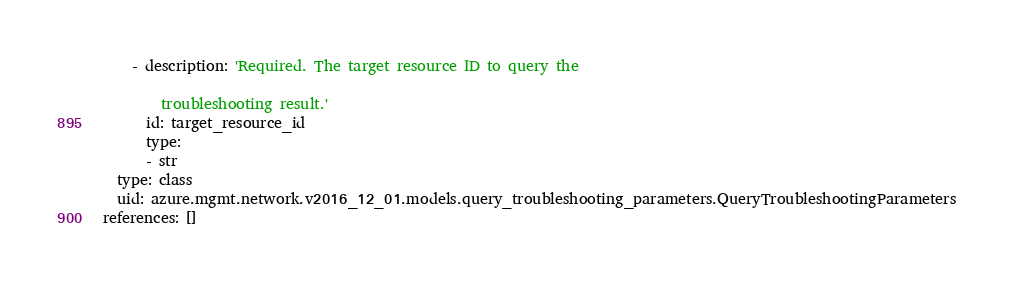Convert code to text. <code><loc_0><loc_0><loc_500><loc_500><_YAML_>    - description: 'Required. The target resource ID to query the

        troubleshooting result.'
      id: target_resource_id
      type:
      - str
  type: class
  uid: azure.mgmt.network.v2016_12_01.models.query_troubleshooting_parameters.QueryTroubleshootingParameters
references: []
</code> 